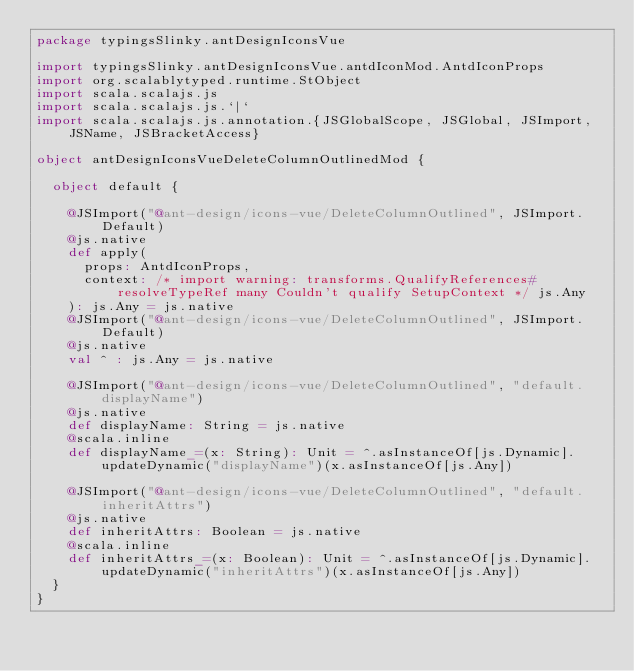Convert code to text. <code><loc_0><loc_0><loc_500><loc_500><_Scala_>package typingsSlinky.antDesignIconsVue

import typingsSlinky.antDesignIconsVue.antdIconMod.AntdIconProps
import org.scalablytyped.runtime.StObject
import scala.scalajs.js
import scala.scalajs.js.`|`
import scala.scalajs.js.annotation.{JSGlobalScope, JSGlobal, JSImport, JSName, JSBracketAccess}

object antDesignIconsVueDeleteColumnOutlinedMod {
  
  object default {
    
    @JSImport("@ant-design/icons-vue/DeleteColumnOutlined", JSImport.Default)
    @js.native
    def apply(
      props: AntdIconProps,
      context: /* import warning: transforms.QualifyReferences#resolveTypeRef many Couldn't qualify SetupContext */ js.Any
    ): js.Any = js.native
    @JSImport("@ant-design/icons-vue/DeleteColumnOutlined", JSImport.Default)
    @js.native
    val ^ : js.Any = js.native
    
    @JSImport("@ant-design/icons-vue/DeleteColumnOutlined", "default.displayName")
    @js.native
    def displayName: String = js.native
    @scala.inline
    def displayName_=(x: String): Unit = ^.asInstanceOf[js.Dynamic].updateDynamic("displayName")(x.asInstanceOf[js.Any])
    
    @JSImport("@ant-design/icons-vue/DeleteColumnOutlined", "default.inheritAttrs")
    @js.native
    def inheritAttrs: Boolean = js.native
    @scala.inline
    def inheritAttrs_=(x: Boolean): Unit = ^.asInstanceOf[js.Dynamic].updateDynamic("inheritAttrs")(x.asInstanceOf[js.Any])
  }
}
</code> 